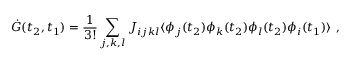<formula> <loc_0><loc_0><loc_500><loc_500>\dot { G } ( t _ { 2 } , t _ { 1 } ) = \frac { 1 } { 3 ! } \sum _ { j , k , l } J _ { i j k l } \langle \phi _ { j } ( t _ { 2 } ) \phi _ { k } ( t _ { 2 } ) \phi _ { l } ( t _ { 2 } ) \phi _ { i } ( t _ { 1 } ) \rangle ,</formula> 